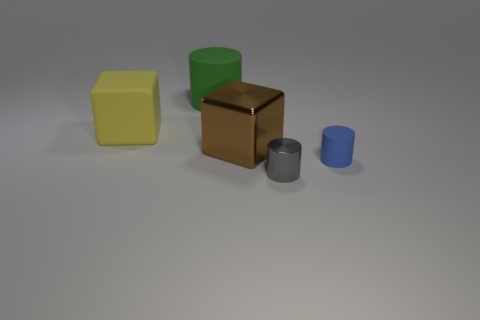There is a cube to the right of the matte cube; how many large metallic cubes are to the right of it?
Your answer should be very brief. 0. There is a blue object that is the same size as the gray object; what is its material?
Ensure brevity in your answer.  Rubber. What number of other things are the same material as the gray thing?
Offer a terse response. 1. There is a big brown shiny object; how many things are left of it?
Your answer should be very brief. 2. What number of cylinders are either small blue objects or green things?
Provide a succinct answer. 2. There is a thing that is on the right side of the brown block and behind the small gray cylinder; how big is it?
Ensure brevity in your answer.  Small. What number of other things are there of the same color as the large cylinder?
Give a very brief answer. 0. Do the large brown block and the cylinder behind the yellow matte thing have the same material?
Your answer should be very brief. No. What number of objects are either cylinders that are behind the brown metal block or small purple things?
Your response must be concise. 1. There is a object that is on the left side of the gray object and to the right of the large green thing; what shape is it?
Keep it short and to the point. Cube. 